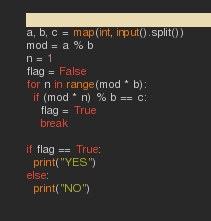Convert code to text. <code><loc_0><loc_0><loc_500><loc_500><_Python_>a, b, c = map(int, input().split())
mod = a % b
n = 1
flag = False
for n in range(mod * b):
  if (mod * n) % b == c:
    flag = True
    break

if flag == True:
  print("YES")
else:
  print("NO")</code> 